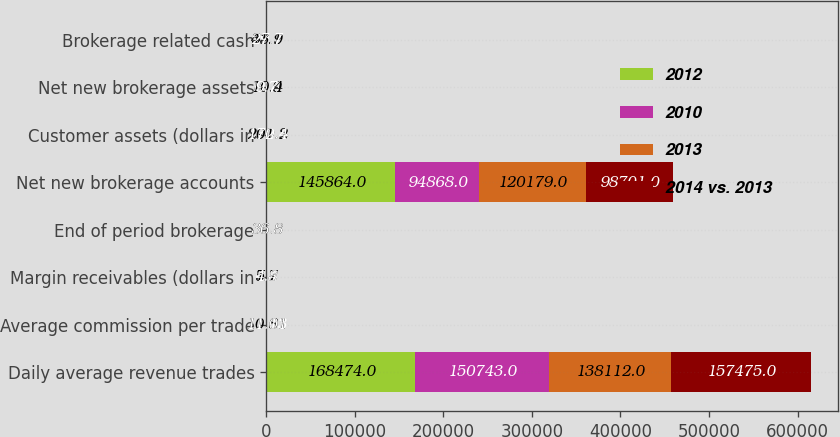Convert chart to OTSL. <chart><loc_0><loc_0><loc_500><loc_500><stacked_bar_chart><ecel><fcel>Daily average revenue trades<fcel>Average commission per trade<fcel>Margin receivables (dollars in<fcel>End of period brokerage<fcel>Net new brokerage accounts<fcel>Customer assets (dollars in<fcel>Net new brokerage assets<fcel>Brokerage related cash<nl><fcel>2012<fcel>168474<fcel>10.81<fcel>7.7<fcel>36.8<fcel>145864<fcel>290.3<fcel>10.9<fcel>41.1<nl><fcel>2010<fcel>150743<fcel>11.13<fcel>6.4<fcel>36.8<fcel>94868<fcel>260.8<fcel>10.4<fcel>39.7<nl><fcel>2013<fcel>138112<fcel>11.01<fcel>5.8<fcel>36.8<fcel>120179<fcel>201.2<fcel>10.4<fcel>33.9<nl><fcel>2014 vs. 2013<fcel>157475<fcel>11.01<fcel>4.8<fcel>36.8<fcel>98701<fcel>172.4<fcel>9.7<fcel>27.7<nl></chart> 